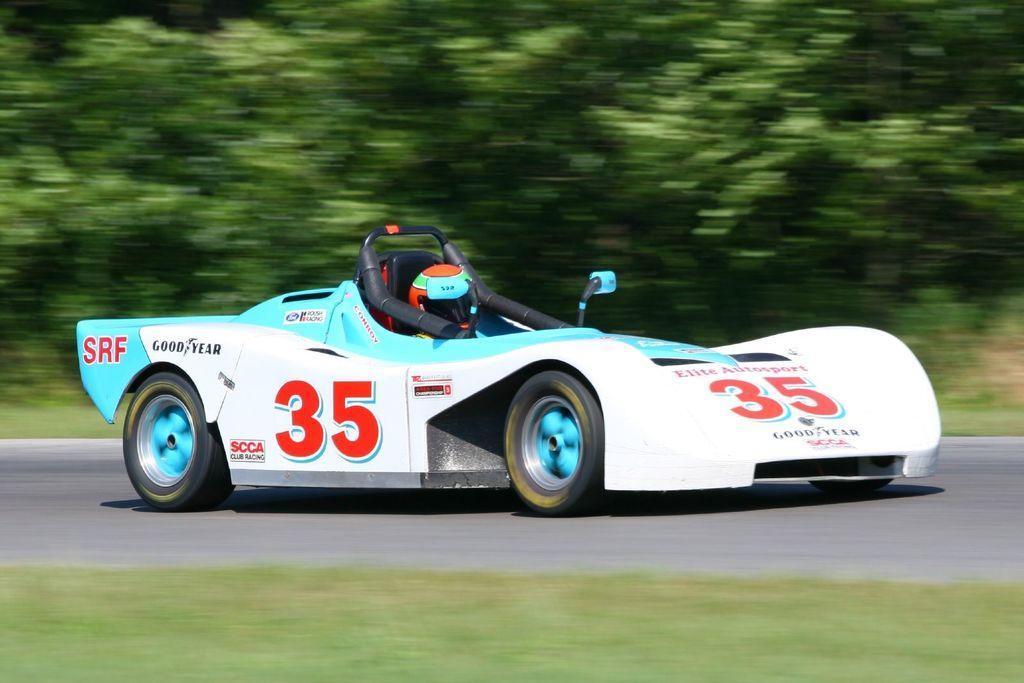What is on the road in the image? There is a vehicle on the road in the image. Who or what is inside the vehicle? There is a person in the vehicle. What can be seen in the distance in the image? There are trees in the background of the image. How would you describe the quality of the image? The image is blurry. What type of collar can be seen on the land in the image? There is no collar present in the image, nor is there any land visible. 